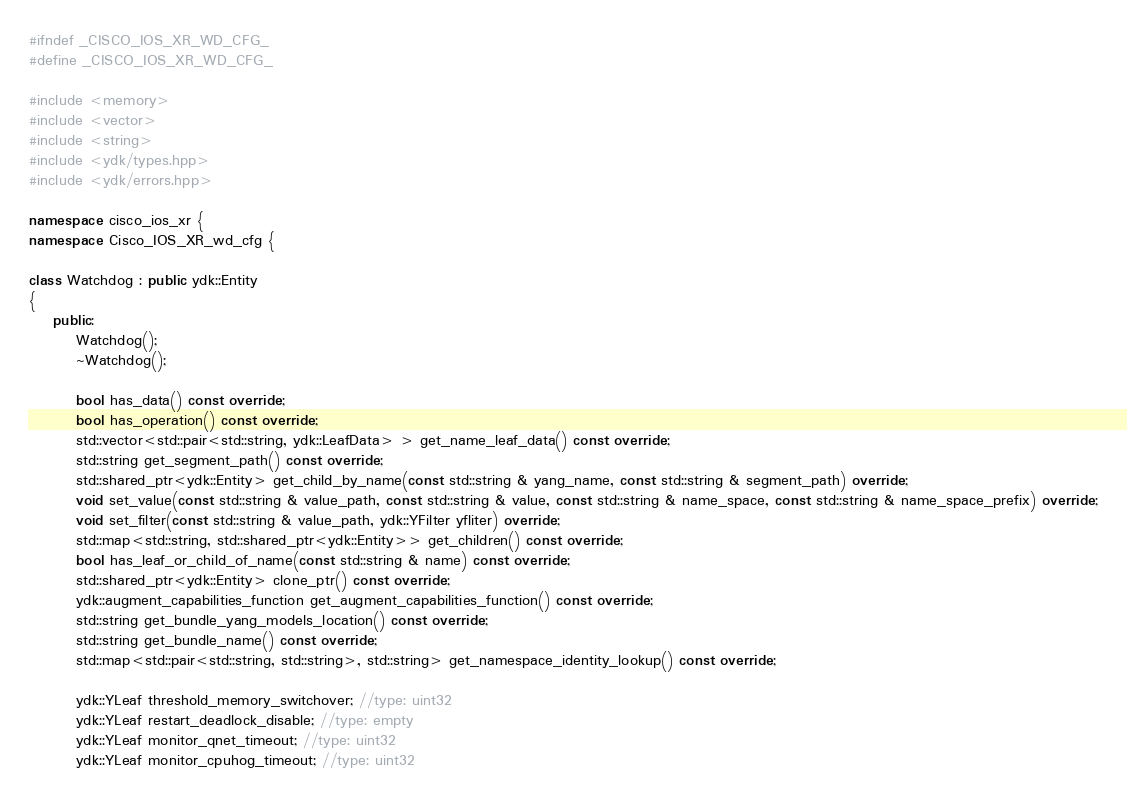Convert code to text. <code><loc_0><loc_0><loc_500><loc_500><_C++_>#ifndef _CISCO_IOS_XR_WD_CFG_
#define _CISCO_IOS_XR_WD_CFG_

#include <memory>
#include <vector>
#include <string>
#include <ydk/types.hpp>
#include <ydk/errors.hpp>

namespace cisco_ios_xr {
namespace Cisco_IOS_XR_wd_cfg {

class Watchdog : public ydk::Entity
{
    public:
        Watchdog();
        ~Watchdog();

        bool has_data() const override;
        bool has_operation() const override;
        std::vector<std::pair<std::string, ydk::LeafData> > get_name_leaf_data() const override;
        std::string get_segment_path() const override;
        std::shared_ptr<ydk::Entity> get_child_by_name(const std::string & yang_name, const std::string & segment_path) override;
        void set_value(const std::string & value_path, const std::string & value, const std::string & name_space, const std::string & name_space_prefix) override;
        void set_filter(const std::string & value_path, ydk::YFilter yfliter) override;
        std::map<std::string, std::shared_ptr<ydk::Entity>> get_children() const override;
        bool has_leaf_or_child_of_name(const std::string & name) const override;
        std::shared_ptr<ydk::Entity> clone_ptr() const override;
        ydk::augment_capabilities_function get_augment_capabilities_function() const override;
        std::string get_bundle_yang_models_location() const override;
        std::string get_bundle_name() const override;
        std::map<std::pair<std::string, std::string>, std::string> get_namespace_identity_lookup() const override;

        ydk::YLeaf threshold_memory_switchover; //type: uint32
        ydk::YLeaf restart_deadlock_disable; //type: empty
        ydk::YLeaf monitor_qnet_timeout; //type: uint32
        ydk::YLeaf monitor_cpuhog_timeout; //type: uint32</code> 